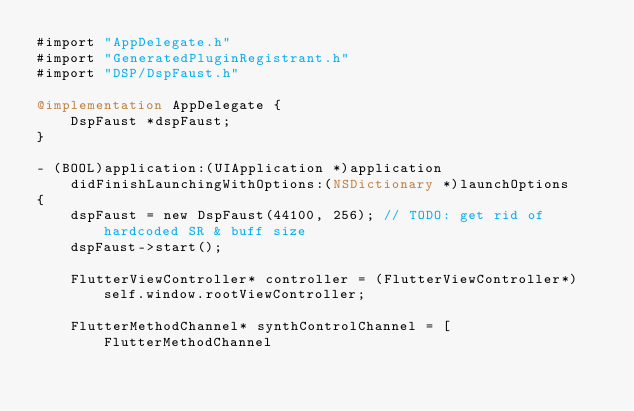Convert code to text. <code><loc_0><loc_0><loc_500><loc_500><_ObjectiveC_>#import "AppDelegate.h"
#import "GeneratedPluginRegistrant.h"
#import "DSP/DspFaust.h"

@implementation AppDelegate {
    DspFaust *dspFaust;
}

- (BOOL)application:(UIApplication *)application
    didFinishLaunchingWithOptions:(NSDictionary *)launchOptions
{
    dspFaust = new DspFaust(44100, 256); // TODO: get rid of hardcoded SR & buff size
    dspFaust->start();
    
    FlutterViewController* controller = (FlutterViewController*)self.window.rootViewController;
    
    FlutterMethodChannel* synthControlChannel = [FlutterMethodChannel</code> 